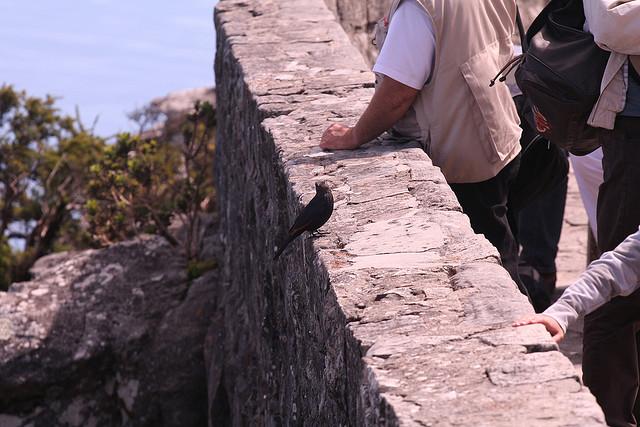What animal is in the picture?
Be succinct. Bird. How many stones make up the wall?
Concise answer only. Lot. How many strings are on the person's backpack?
Concise answer only. 2. 